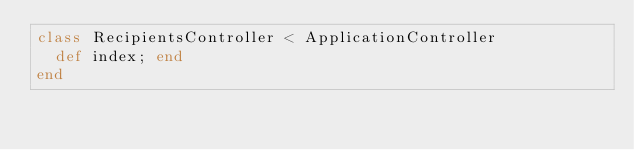<code> <loc_0><loc_0><loc_500><loc_500><_Ruby_>class RecipientsController < ApplicationController
  def index; end
end
</code> 